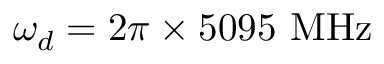<formula> <loc_0><loc_0><loc_500><loc_500>\omega _ { d } = 2 \pi \times 5 0 9 5 M H z</formula> 